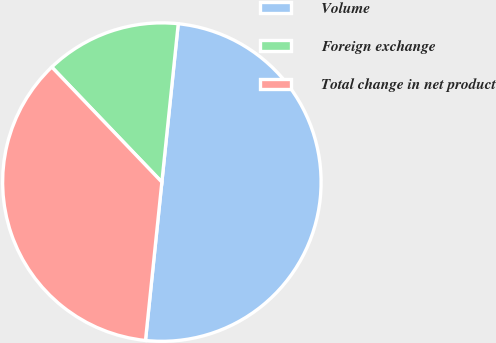<chart> <loc_0><loc_0><loc_500><loc_500><pie_chart><fcel>Volume<fcel>Foreign exchange<fcel>Total change in net product<nl><fcel>50.0%<fcel>13.79%<fcel>36.21%<nl></chart> 